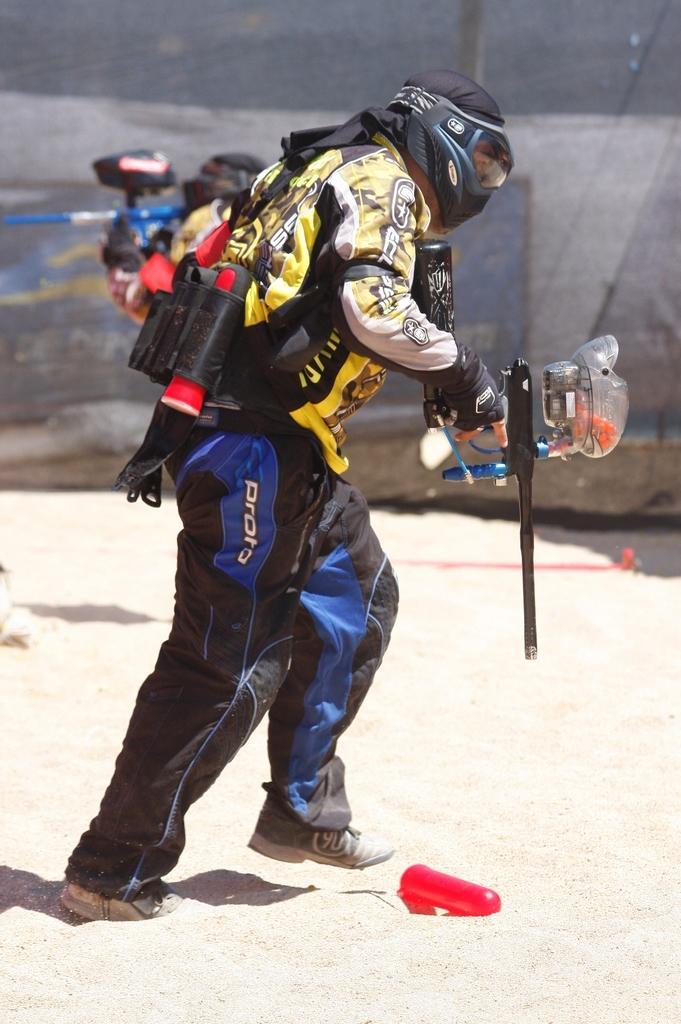How would you summarize this image in a sentence or two? In this picture we can see a person is walking and holding something, this person is wearing a mask, gloves and shoes, at the bottom there is sand, we can see a blurry background. 